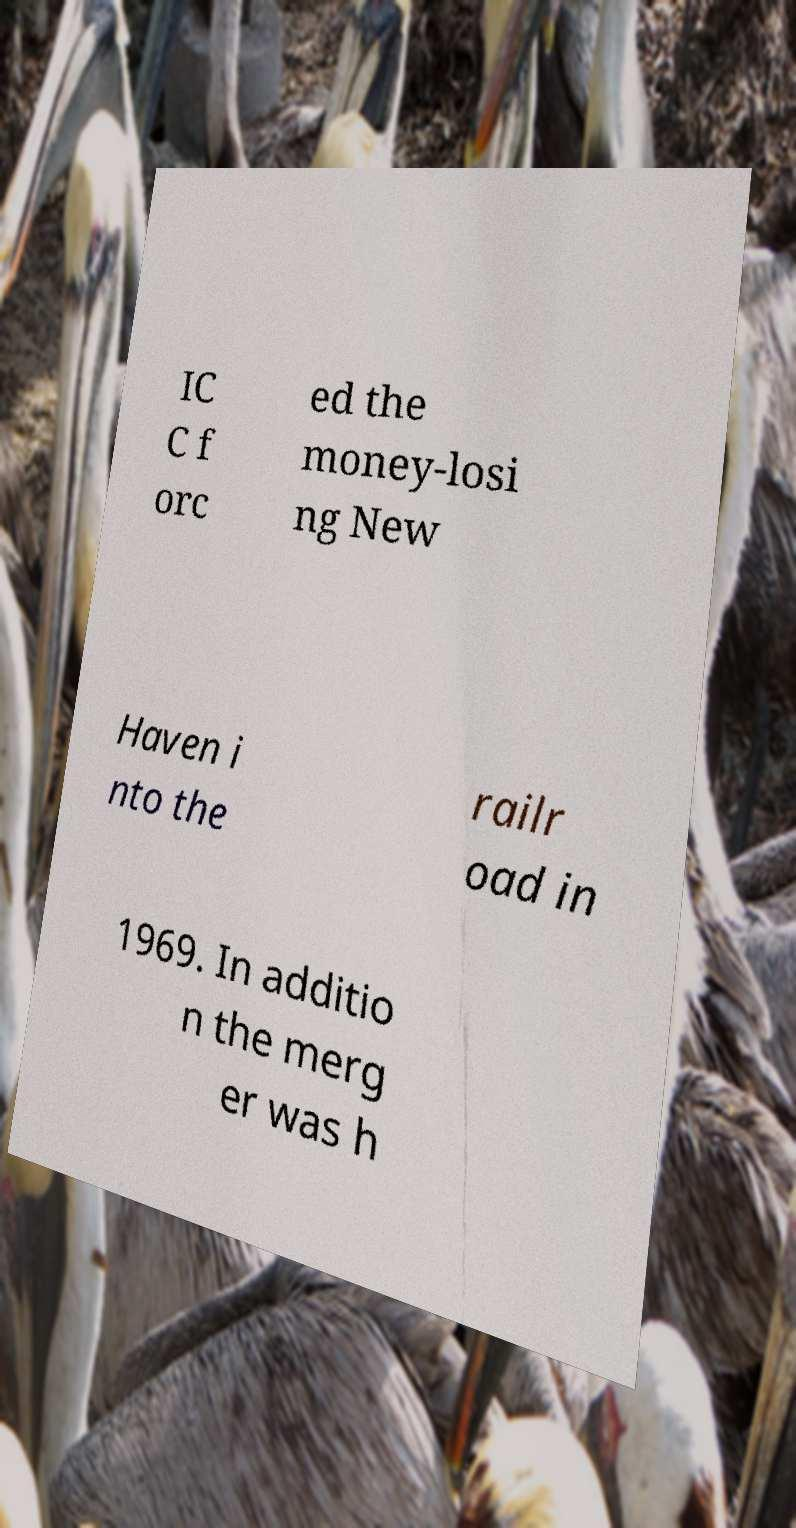There's text embedded in this image that I need extracted. Can you transcribe it verbatim? IC C f orc ed the money-losi ng New Haven i nto the railr oad in 1969. In additio n the merg er was h 